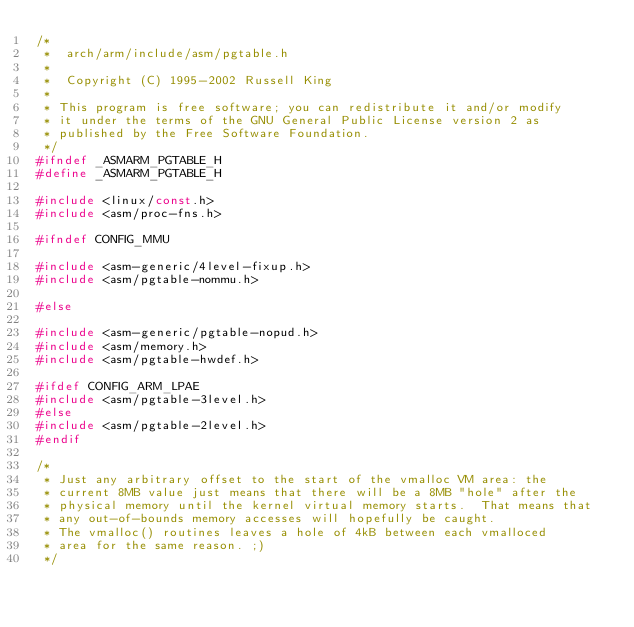<code> <loc_0><loc_0><loc_500><loc_500><_C_>/*
 *  arch/arm/include/asm/pgtable.h
 *
 *  Copyright (C) 1995-2002 Russell King
 *
 * This program is free software; you can redistribute it and/or modify
 * it under the terms of the GNU General Public License version 2 as
 * published by the Free Software Foundation.
 */
#ifndef _ASMARM_PGTABLE_H
#define _ASMARM_PGTABLE_H

#include <linux/const.h>
#include <asm/proc-fns.h>

#ifndef CONFIG_MMU

#include <asm-generic/4level-fixup.h>
#include <asm/pgtable-nommu.h>

#else

#include <asm-generic/pgtable-nopud.h>
#include <asm/memory.h>
#include <asm/pgtable-hwdef.h>

#ifdef CONFIG_ARM_LPAE
#include <asm/pgtable-3level.h>
#else
#include <asm/pgtable-2level.h>
#endif

/*
 * Just any arbitrary offset to the start of the vmalloc VM area: the
 * current 8MB value just means that there will be a 8MB "hole" after the
 * physical memory until the kernel virtual memory starts.  That means that
 * any out-of-bounds memory accesses will hopefully be caught.
 * The vmalloc() routines leaves a hole of 4kB between each vmalloced
 * area for the same reason. ;)
 */</code> 